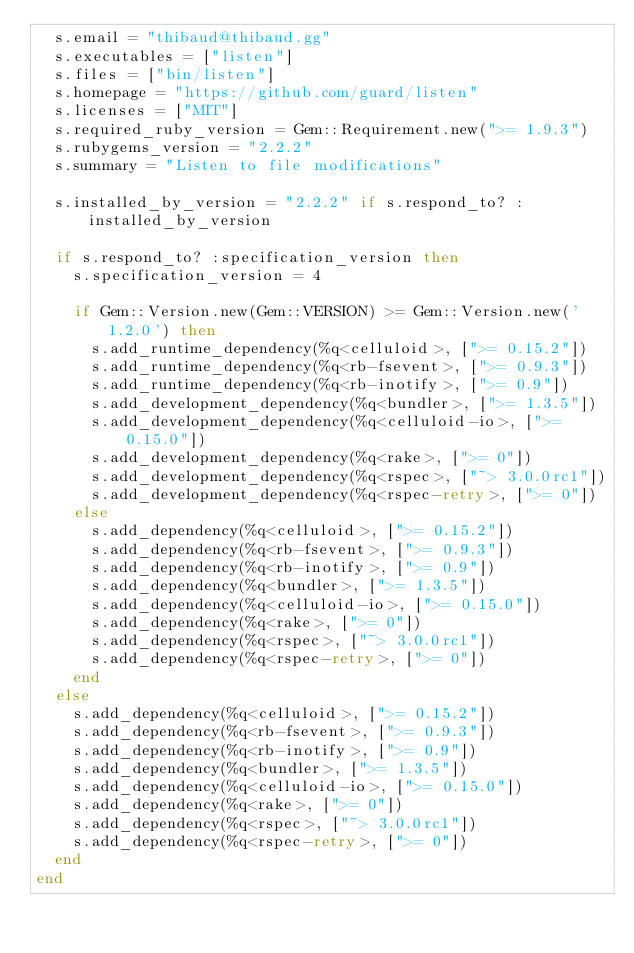<code> <loc_0><loc_0><loc_500><loc_500><_Ruby_>  s.email = "thibaud@thibaud.gg"
  s.executables = ["listen"]
  s.files = ["bin/listen"]
  s.homepage = "https://github.com/guard/listen"
  s.licenses = ["MIT"]
  s.required_ruby_version = Gem::Requirement.new(">= 1.9.3")
  s.rubygems_version = "2.2.2"
  s.summary = "Listen to file modifications"

  s.installed_by_version = "2.2.2" if s.respond_to? :installed_by_version

  if s.respond_to? :specification_version then
    s.specification_version = 4

    if Gem::Version.new(Gem::VERSION) >= Gem::Version.new('1.2.0') then
      s.add_runtime_dependency(%q<celluloid>, [">= 0.15.2"])
      s.add_runtime_dependency(%q<rb-fsevent>, [">= 0.9.3"])
      s.add_runtime_dependency(%q<rb-inotify>, [">= 0.9"])
      s.add_development_dependency(%q<bundler>, [">= 1.3.5"])
      s.add_development_dependency(%q<celluloid-io>, [">= 0.15.0"])
      s.add_development_dependency(%q<rake>, [">= 0"])
      s.add_development_dependency(%q<rspec>, ["~> 3.0.0rc1"])
      s.add_development_dependency(%q<rspec-retry>, [">= 0"])
    else
      s.add_dependency(%q<celluloid>, [">= 0.15.2"])
      s.add_dependency(%q<rb-fsevent>, [">= 0.9.3"])
      s.add_dependency(%q<rb-inotify>, [">= 0.9"])
      s.add_dependency(%q<bundler>, [">= 1.3.5"])
      s.add_dependency(%q<celluloid-io>, [">= 0.15.0"])
      s.add_dependency(%q<rake>, [">= 0"])
      s.add_dependency(%q<rspec>, ["~> 3.0.0rc1"])
      s.add_dependency(%q<rspec-retry>, [">= 0"])
    end
  else
    s.add_dependency(%q<celluloid>, [">= 0.15.2"])
    s.add_dependency(%q<rb-fsevent>, [">= 0.9.3"])
    s.add_dependency(%q<rb-inotify>, [">= 0.9"])
    s.add_dependency(%q<bundler>, [">= 1.3.5"])
    s.add_dependency(%q<celluloid-io>, [">= 0.15.0"])
    s.add_dependency(%q<rake>, [">= 0"])
    s.add_dependency(%q<rspec>, ["~> 3.0.0rc1"])
    s.add_dependency(%q<rspec-retry>, [">= 0"])
  end
end
</code> 